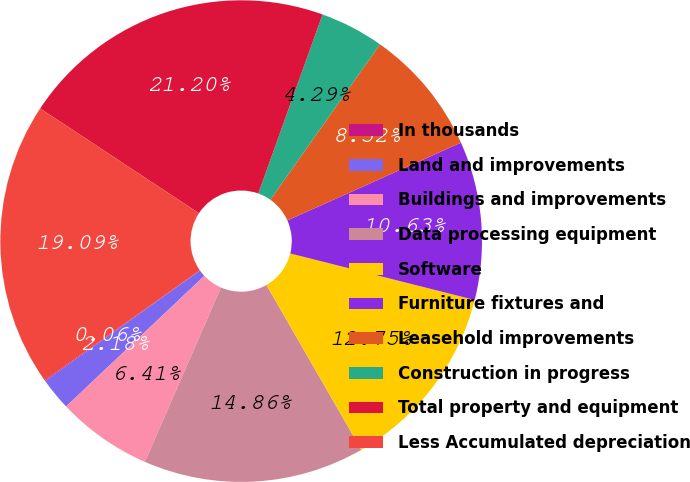<chart> <loc_0><loc_0><loc_500><loc_500><pie_chart><fcel>In thousands<fcel>Land and improvements<fcel>Buildings and improvements<fcel>Data processing equipment<fcel>Software<fcel>Furniture fixtures and<fcel>Leasehold improvements<fcel>Construction in progress<fcel>Total property and equipment<fcel>Less Accumulated depreciation<nl><fcel>0.06%<fcel>2.18%<fcel>6.41%<fcel>14.86%<fcel>12.75%<fcel>10.63%<fcel>8.52%<fcel>4.29%<fcel>21.2%<fcel>19.09%<nl></chart> 